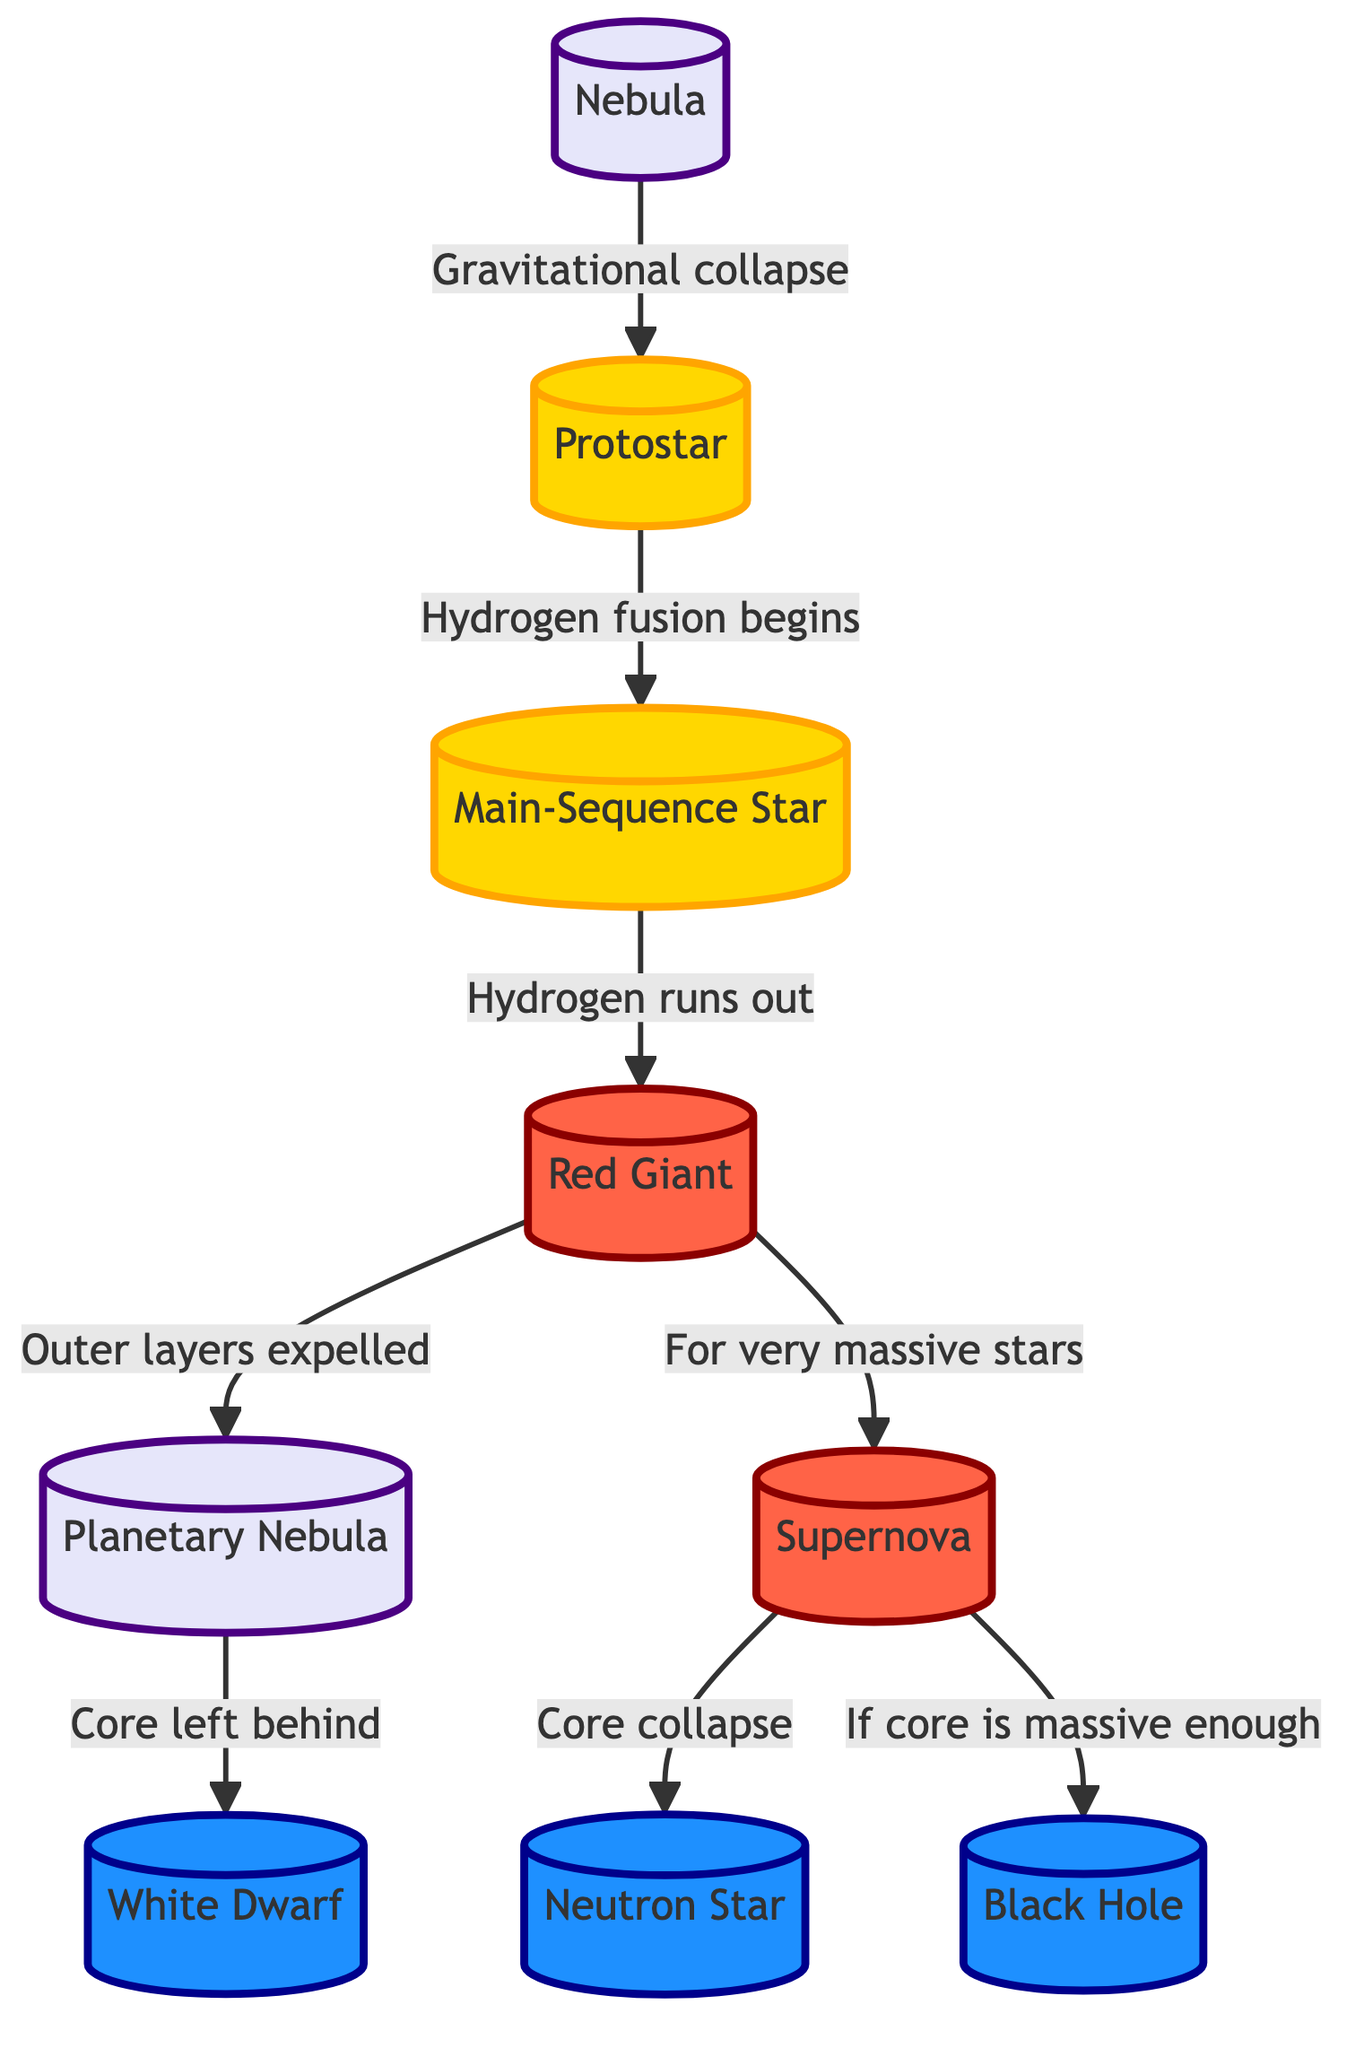What is the first stage of a star's lifecycle? The diagram shows "Nebula" at the top, indicating it is the starting point or first stage in the lifecycle of a star.
Answer: Nebula How many endpoints are possible for a star? The diagram outlines three possible endpoints for a star: "White Dwarf," "Neutron Star," and "Black Hole," indicating there are three distinct outcomes after a star's lifecycle.
Answer: 3 What happens to a main-sequence star when hydrogen runs out? The diagram shows an arrow from "Main-Sequence Star" to "Red Giant," which indicates that the next stage is that the star becomes a Red Giant after exhausting its hydrogen supply.
Answer: Red Giant Which stage follows the "Supernova"? According to the diagram, the "Supernova" stage can lead to either a "Neutron Star" or a "Black Hole," depending on the mass of the core left behind after the explosion.
Answer: Neutron Star or Black Hole What process transforms a protostar into a main-sequence star? The diagram specifies that "Hydrogen fusion begins" as the transformation process that occurs when a protostar develops into a main-sequence star.
Answer: Hydrogen fusion begins What is created when the outer layers of a Red Giant are expelled? The diagram indicates that expelling the outer layers of a Red Giant results in the formation of a "Planetary Nebula," thus that is the outcome of that process.
Answer: Planetary Nebula How does a massive star end its life according to the diagram? The diagram shows that for very massive stars, the endpoint is a "Supernova," which is a significant event leading to either a "Neutron Star" or a "Black Hole."
Answer: Supernova Which color represents the remnant stages of a star? The diagram uses blue for the remnant stages, visually indicating the colors associated with "White Dwarf," "Neutron Star," and "Black Hole."
Answer: Blue 